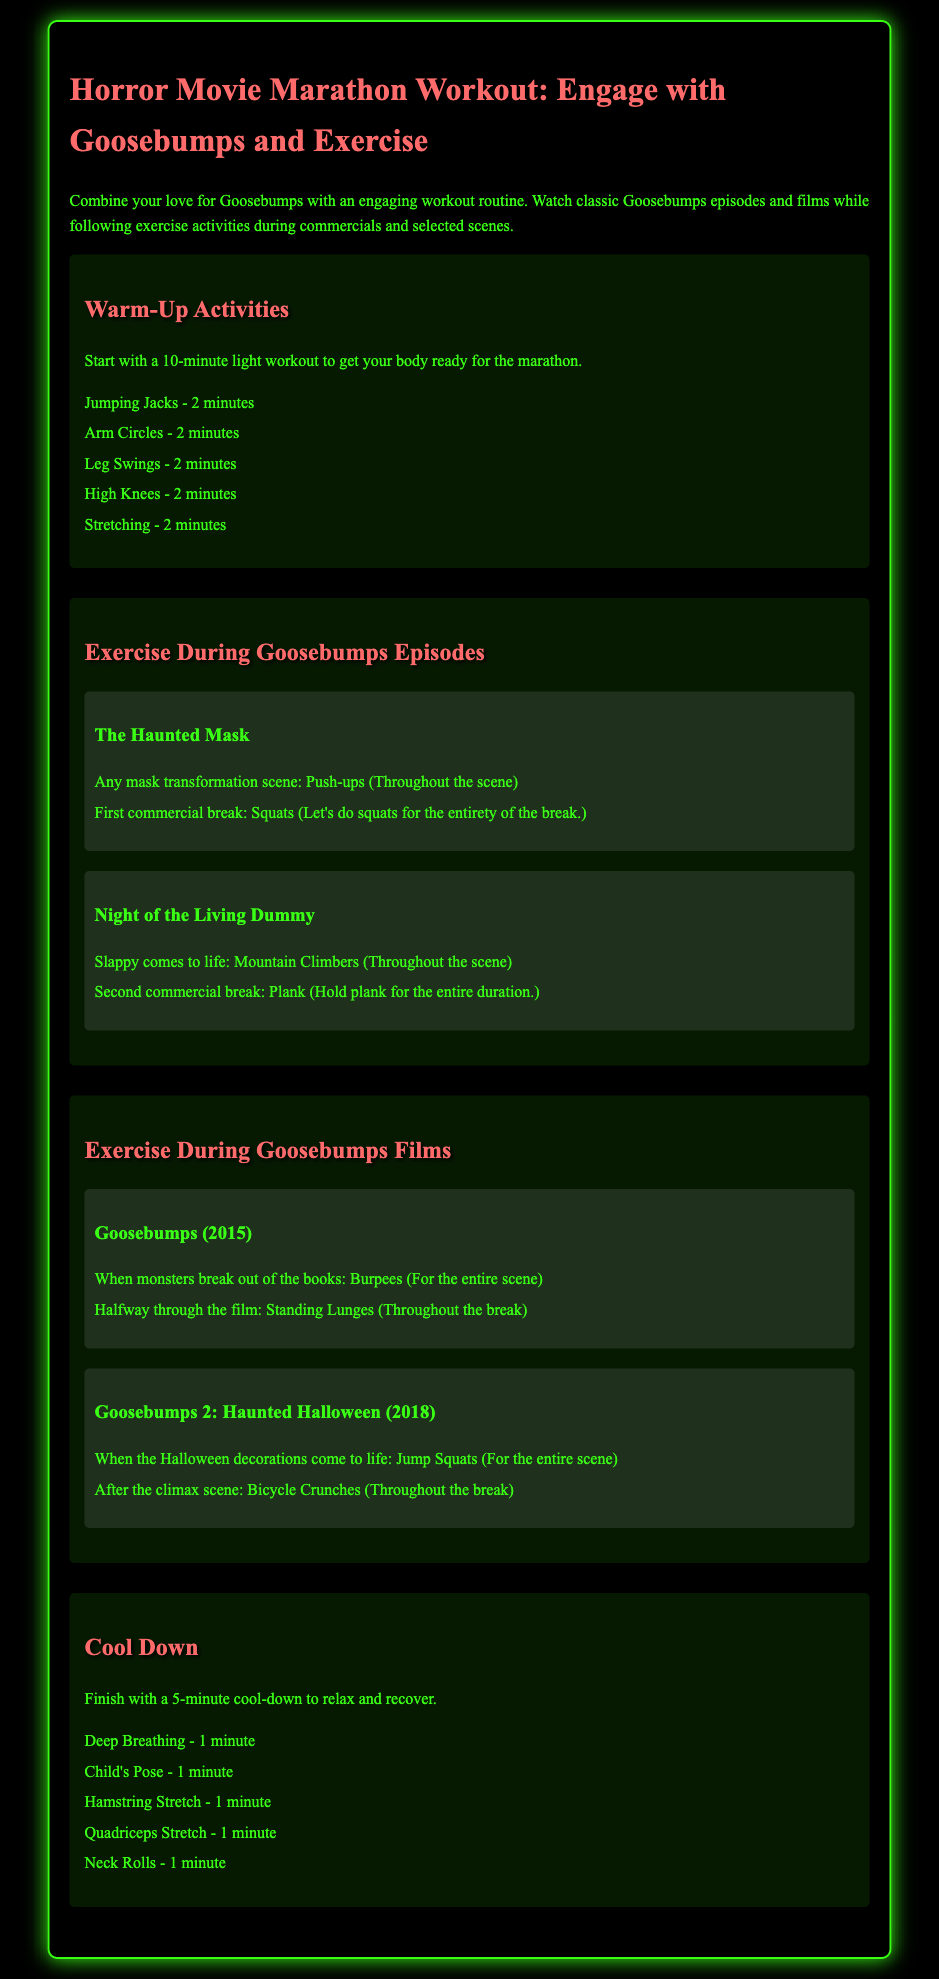what is the title of the workout plan? The title of the workout plan is provided at the beginning of the document.
Answer: Horror Movie Marathon Workout: Engage with Goosebumps and Exercise how long should the warm-up activities last? The document specifies the duration of the warm-up activities.
Answer: 10 minutes which episode features slappy coming to life? The document names the Goosebumps episode featuring this event.
Answer: Night of the Living Dummy during which film do you do burpees when monsters break out of the books? The film referenced includes specific exercises tied to its scenes.
Answer: Goosebumps (2015) name one activity to do during the first commercial break of The Haunted Mask. The document outlines the activities for this specific break in the episode.
Answer: Squats how many minutes should the cool-down last? The duration of the cool-down is explicitly mentioned in the document.
Answer: 5 minutes what exercise is recommended during the Halloween decorations scene? The document correlates specific exercises to particular scenes in the film.
Answer: Jump Squats what is one of the warm-up activities listed? The warm-up section contains various exercises that can be selected.
Answer: Jumping Jacks what should you do during the second commercial break of Night of the Living Dummy? The document indicates the exercise for this specific break.
Answer: Plank 